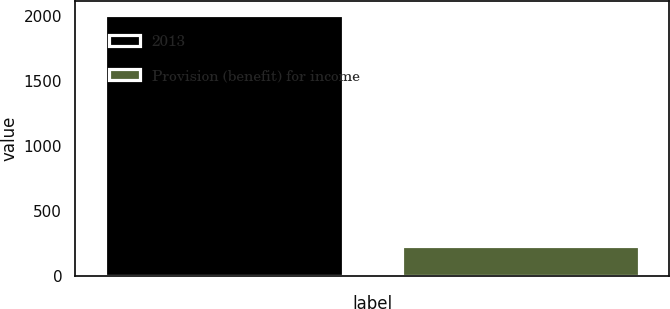Convert chart to OTSL. <chart><loc_0><loc_0><loc_500><loc_500><bar_chart><fcel>2013<fcel>Provision (benefit) for income<nl><fcel>2012<fcel>229<nl></chart> 